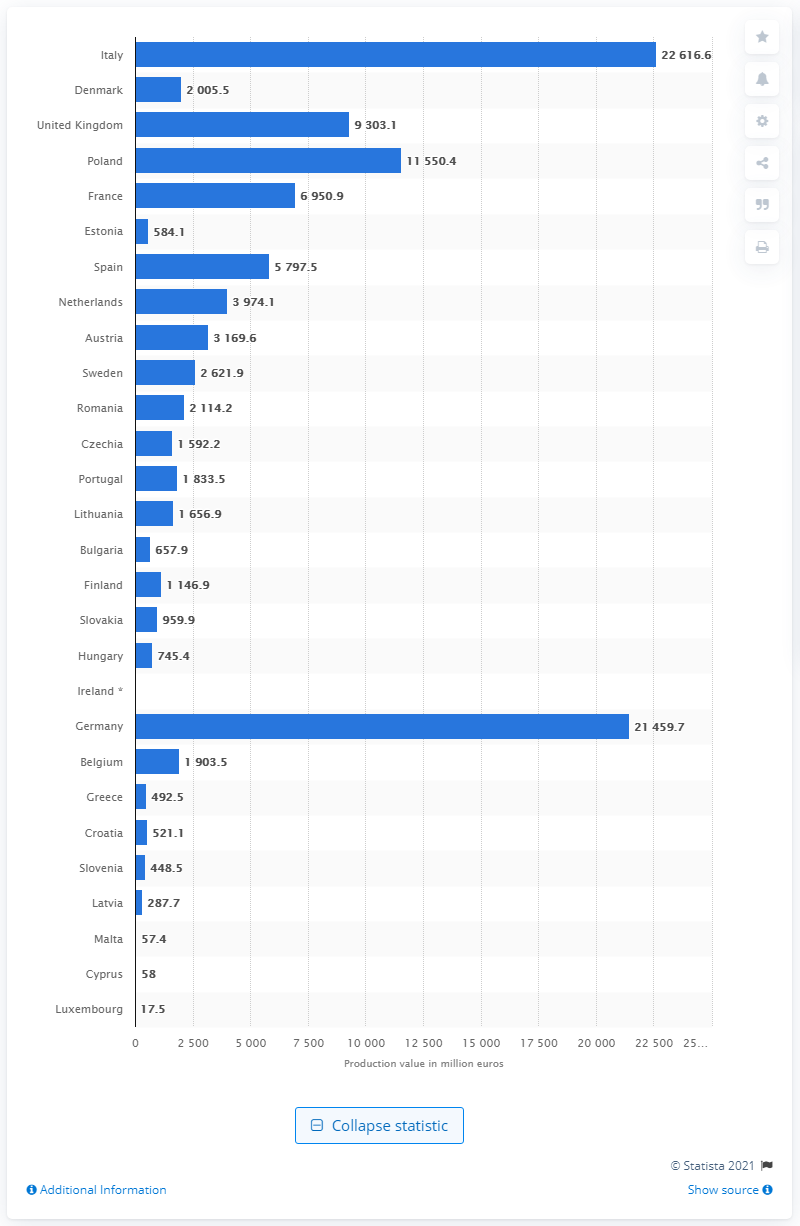Point out several critical features in this image. The production value of furniture in Italy in 2018 was 22,616.6 million euros. 